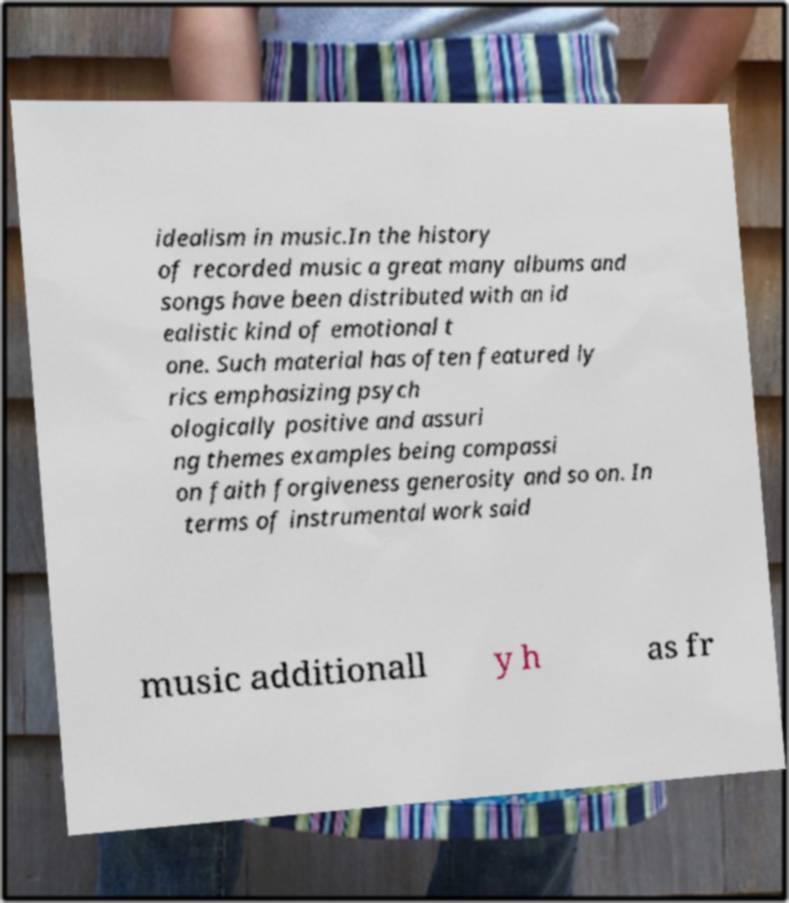Please read and relay the text visible in this image. What does it say? idealism in music.In the history of recorded music a great many albums and songs have been distributed with an id ealistic kind of emotional t one. Such material has often featured ly rics emphasizing psych ologically positive and assuri ng themes examples being compassi on faith forgiveness generosity and so on. In terms of instrumental work said music additionall y h as fr 